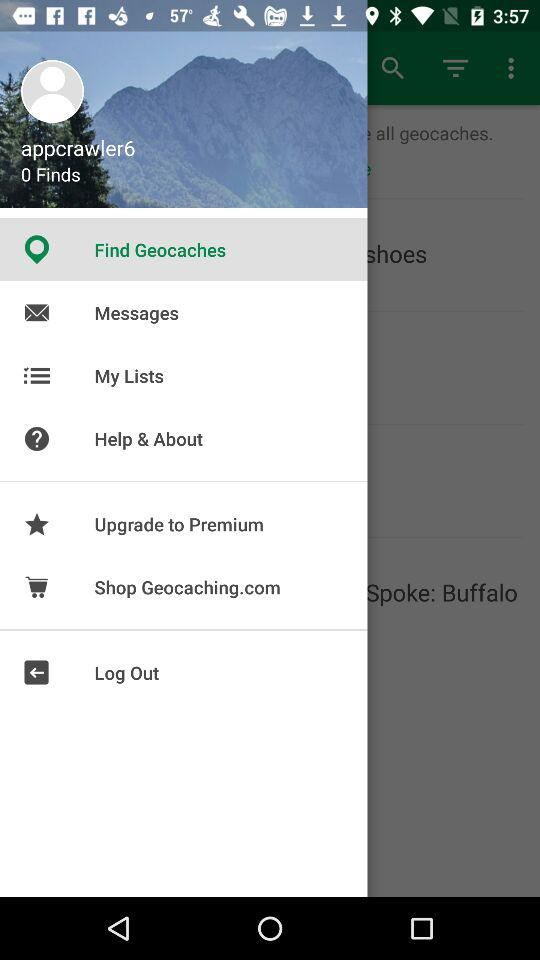What is the selected item in the menu? The selected item in the menu is "Find Geocaches". 